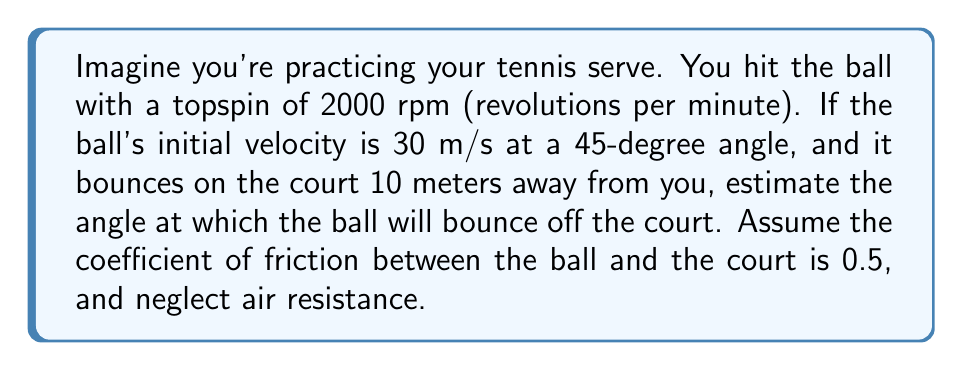Help me with this question. Let's approach this step-by-step:

1) First, we need to understand how topspin affects the ball's bounce. Topspin causes the ball to dive down more quickly and bounce forward with more energy.

2) The angular velocity of the ball is:
   $$ \omega = 2000 \text{ rpm} \times \frac{2\pi \text{ rad}}{60 \text{ s}} = \frac{200\pi}{3} \text{ rad/s} $$

3) The linear velocity of the ball's surface due to spin is:
   $$ v_s = \omega r $$
   where $r$ is the radius of a tennis ball (approximately 0.033 m)
   $$ v_s = \frac{200\pi}{3} \times 0.033 \approx 6.91 \text{ m/s} $$

4) The horizontal component of the initial velocity is:
   $$ v_x = 30 \cos(45°) \approx 21.21 \text{ m/s} $$

5) The time taken for the ball to travel 10 meters horizontally is:
   $$ t = \frac{10}{21.21} \approx 0.47 \text{ s} $$

6) At the moment of impact, the ball's forward velocity is still approximately 21.21 m/s.

7) The friction force during impact will be:
   $$ F = \mu N $$
   where $\mu$ is the coefficient of friction (0.5) and $N$ is the normal force.

8) This friction force will cause an impulse that changes the ball's velocity. The change in velocity due to friction is proportional to the spin velocity:
   $$ \Delta v \propto v_s $$

9) Assuming the change in velocity is roughly equal to the spin velocity:
   $$ v_{new} = 21.21 + 6.91 = 28.12 \text{ m/s} $$

10) The angle of bounce can be estimated using:
    $$ \theta = \arctan(\frac{v_{new} - v_x}{v_x}) $$
    $$ \theta = \arctan(\frac{28.12 - 21.21}{21.21}) \approx 18.1° $$
Answer: $18.1°$ 